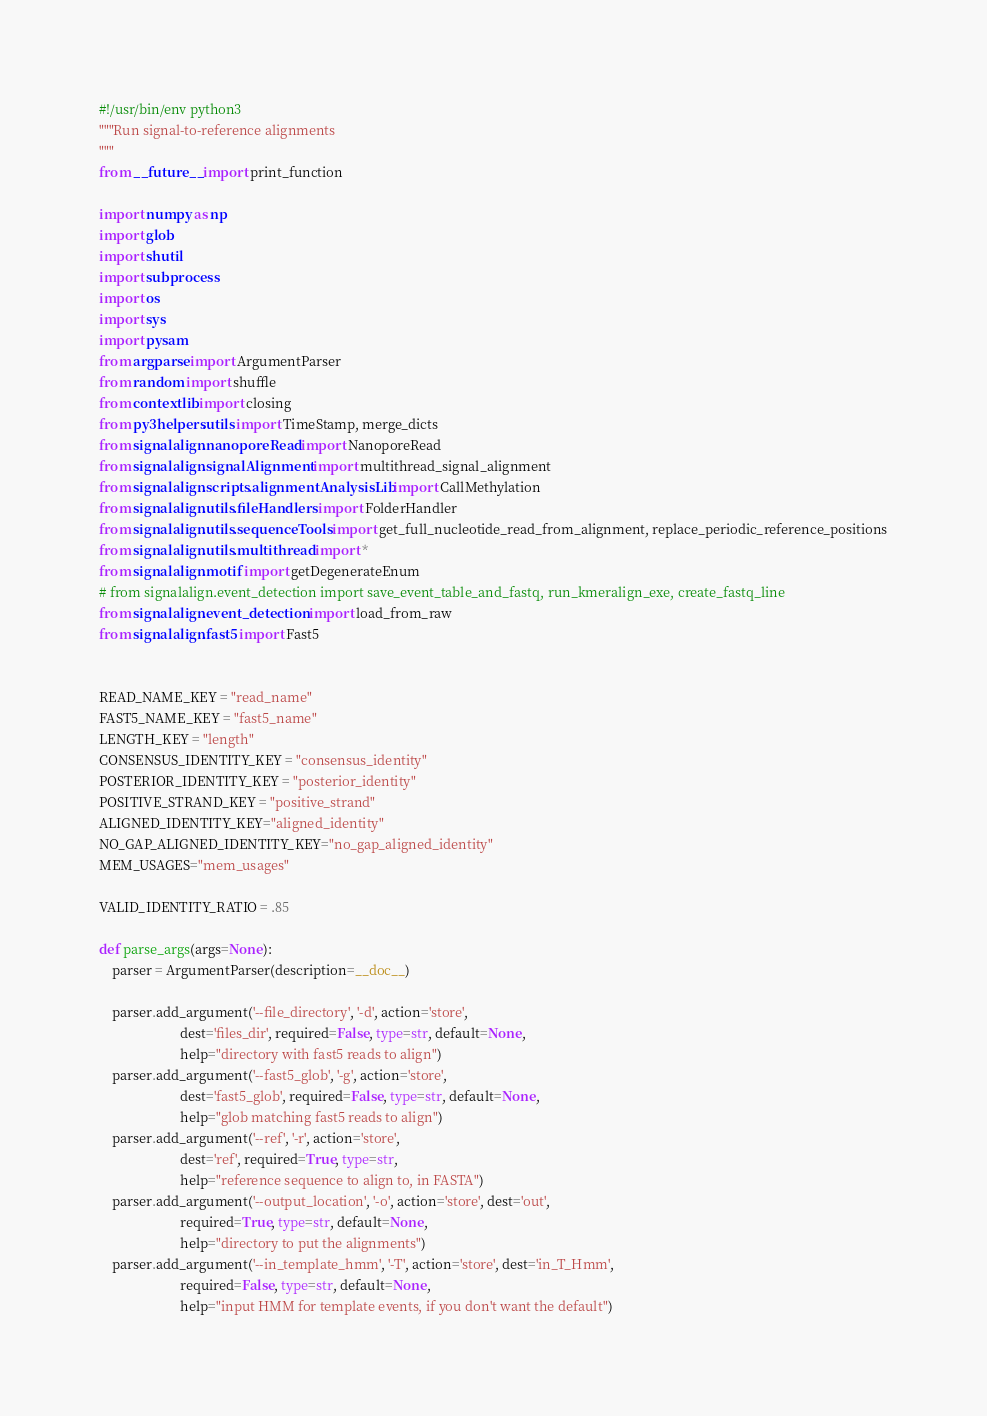<code> <loc_0><loc_0><loc_500><loc_500><_Python_>#!/usr/bin/env python3
"""Run signal-to-reference alignments
"""
from __future__ import print_function

import numpy as np
import glob
import shutil
import subprocess
import os
import sys
import pysam
from argparse import ArgumentParser
from random import shuffle
from contextlib import closing
from py3helpers.utils import TimeStamp, merge_dicts
from signalalign.nanoporeRead import NanoporeRead
from signalalign.signalAlignment import multithread_signal_alignment
from signalalign.scripts.alignmentAnalysisLib import CallMethylation
from signalalign.utils.fileHandlers import FolderHandler
from signalalign.utils.sequenceTools import get_full_nucleotide_read_from_alignment, replace_periodic_reference_positions
from signalalign.utils.multithread import *
from signalalign.motif import getDegenerateEnum
# from signalalign.event_detection import save_event_table_and_fastq, run_kmeralign_exe, create_fastq_line
from signalalign.event_detection import load_from_raw
from signalalign.fast5 import Fast5


READ_NAME_KEY = "read_name"
FAST5_NAME_KEY = "fast5_name"
LENGTH_KEY = "length"
CONSENSUS_IDENTITY_KEY = "consensus_identity"
POSTERIOR_IDENTITY_KEY = "posterior_identity"
POSITIVE_STRAND_KEY = "positive_strand"
ALIGNED_IDENTITY_KEY="aligned_identity"
NO_GAP_ALIGNED_IDENTITY_KEY="no_gap_aligned_identity"
MEM_USAGES="mem_usages"

VALID_IDENTITY_RATIO = .85

def parse_args(args=None):
    parser = ArgumentParser(description=__doc__)

    parser.add_argument('--file_directory', '-d', action='store',
                        dest='files_dir', required=False, type=str, default=None,
                        help="directory with fast5 reads to align")
    parser.add_argument('--fast5_glob', '-g', action='store',
                        dest='fast5_glob', required=False, type=str, default=None,
                        help="glob matching fast5 reads to align")
    parser.add_argument('--ref', '-r', action='store',
                        dest='ref', required=True, type=str,
                        help="reference sequence to align to, in FASTA")
    parser.add_argument('--output_location', '-o', action='store', dest='out',
                        required=True, type=str, default=None,
                        help="directory to put the alignments")
    parser.add_argument('--in_template_hmm', '-T', action='store', dest='in_T_Hmm',
                        required=False, type=str, default=None,
                        help="input HMM for template events, if you don't want the default")</code> 